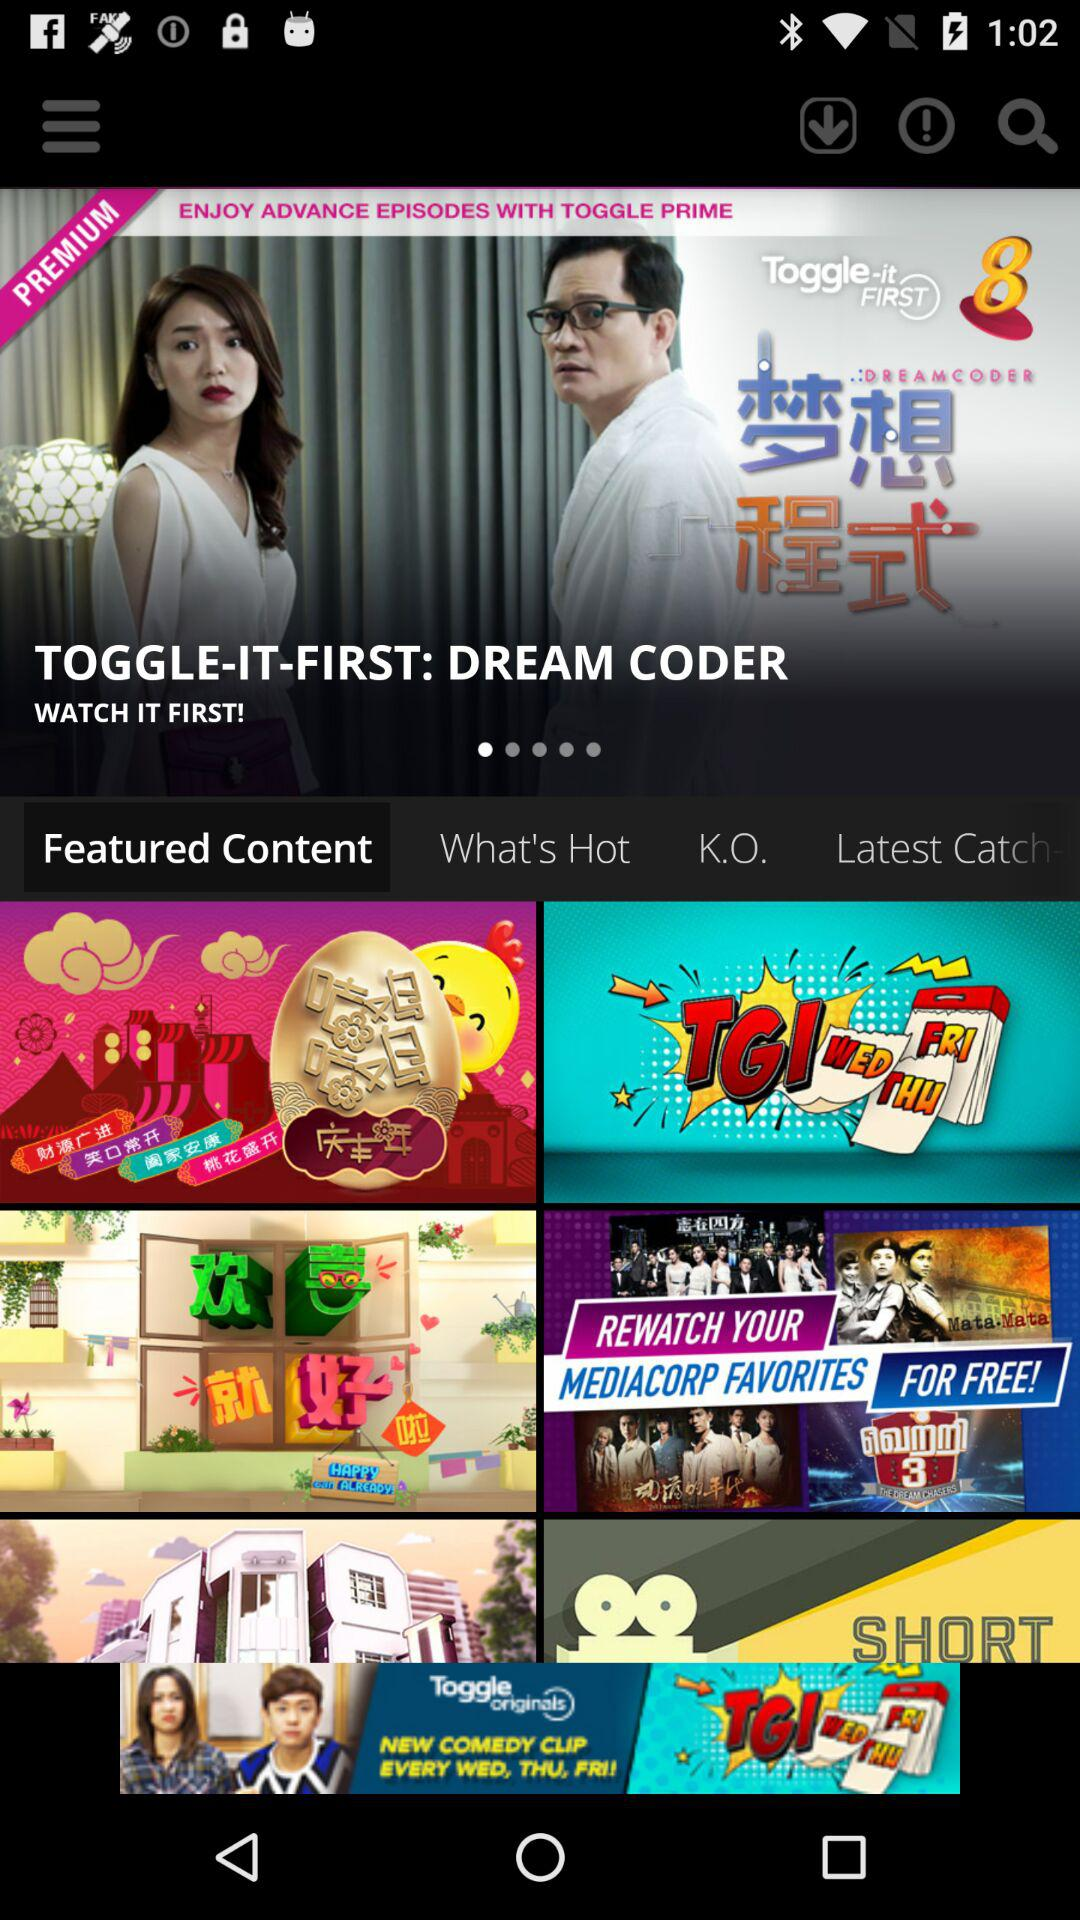Which option is selected on the screen? The selected option is "Featured Content". 